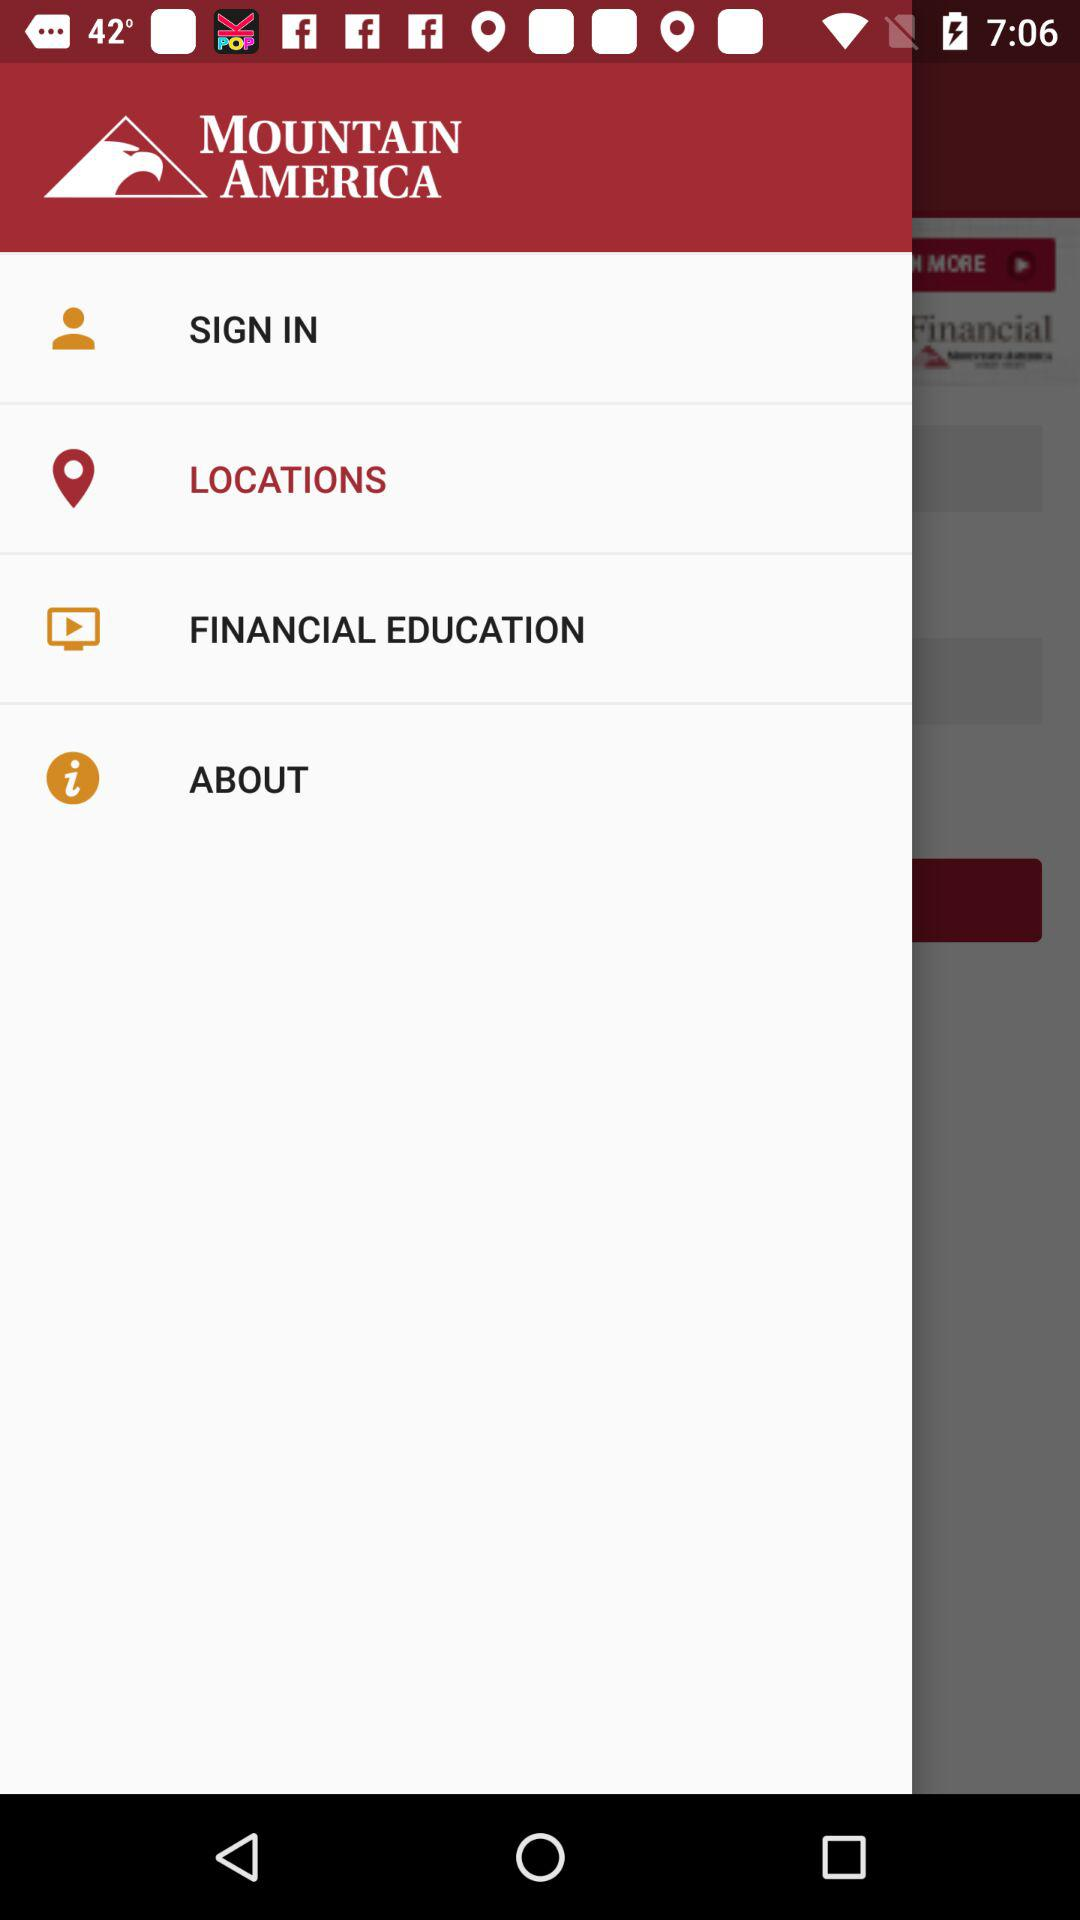What is the name of the application? The name of the application is "MOUNTAIN AMERICA". 